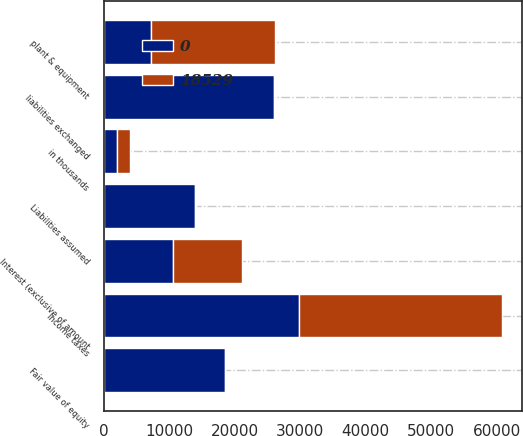<chart> <loc_0><loc_0><loc_500><loc_500><stacked_bar_chart><ecel><fcel>in thousands<fcel>Interest (exclusive of amount<fcel>Income taxes<fcel>plant & equipment<fcel>liabilities exchanged<fcel>Liabilities assumed<fcel>Fair value of equity<nl><fcel>18529<fcel>2013<fcel>10569<fcel>30938<fcel>18864<fcel>0<fcel>232<fcel>0<nl><fcel>0<fcel>2011<fcel>10569<fcel>29874<fcel>7226<fcel>25994<fcel>13912<fcel>18529<nl></chart> 